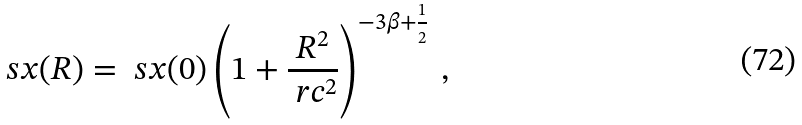Convert formula to latex. <formula><loc_0><loc_0><loc_500><loc_500>\ s x ( R ) = \ s x ( 0 ) \left ( 1 + \frac { R ^ { 2 } } { \ r c ^ { 2 } } \right ) ^ { - 3 \beta + \frac { 1 } { 2 } } \, ,</formula> 